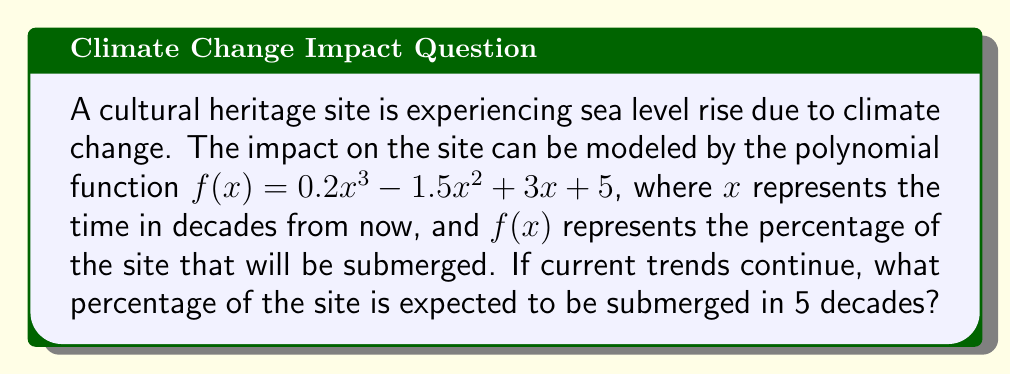Could you help me with this problem? To solve this problem, we need to evaluate the polynomial function $f(x)$ at $x = 5$. Let's break it down step-by-step:

1) The given polynomial function is:
   $f(x) = 0.2x^3 - 1.5x^2 + 3x + 5$

2) We need to calculate $f(5)$, so we substitute $x$ with 5:
   $f(5) = 0.2(5)^3 - 1.5(5)^2 + 3(5) + 5$

3) Let's evaluate each term:
   a) $0.2(5)^3 = 0.2 \times 125 = 25$
   b) $-1.5(5)^2 = -1.5 \times 25 = -37.5$
   c) $3(5) = 15$
   d) The constant term is already 5

4) Now, we sum all these terms:
   $f(5) = 25 - 37.5 + 15 + 5 = 7.5$

Therefore, in 5 decades, 7.5% of the cultural heritage site is expected to be submerged if current climate change trends continue.
Answer: 7.5% 